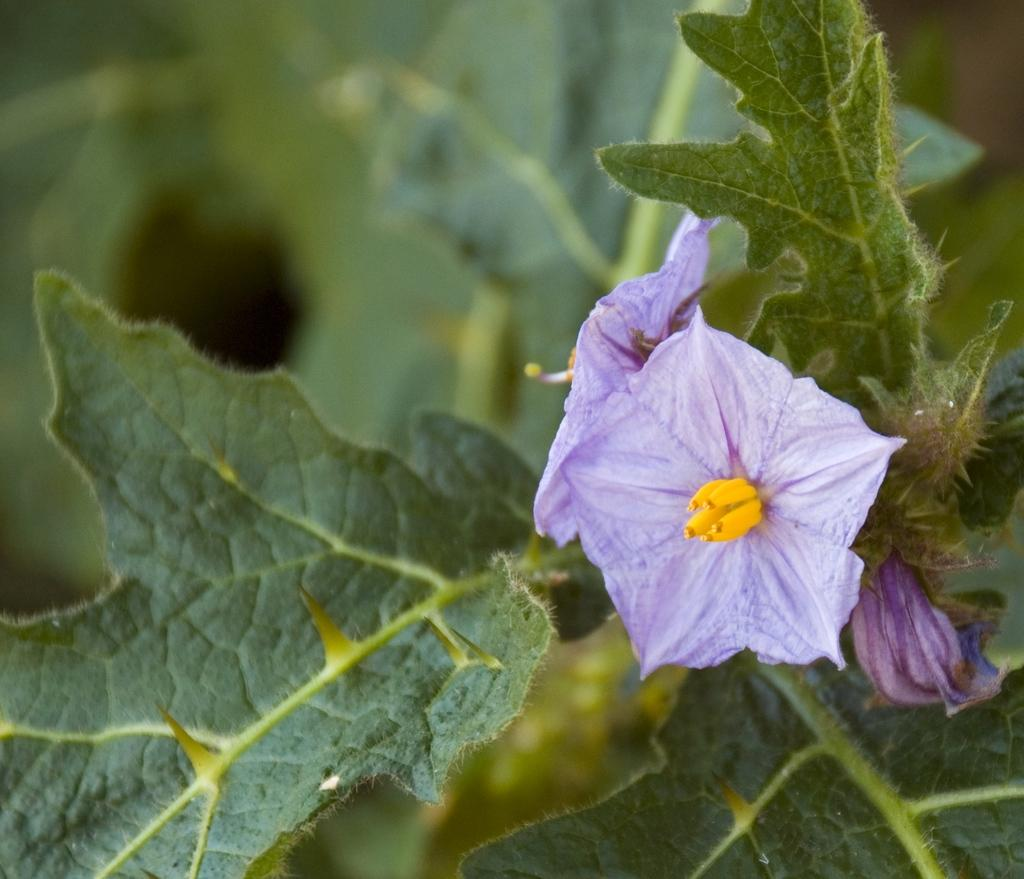What type of living organisms can be seen in the image? There are flowers and a plant visible in the image. Can you describe the background of the image? The background of the image is blurred. What type of property can be seen in the image? There is no property visible in the image; it features flowers and a plant. Can you hear a whistle in the image? There is no whistle present in the image, as it is a still image and not a sound recording. 